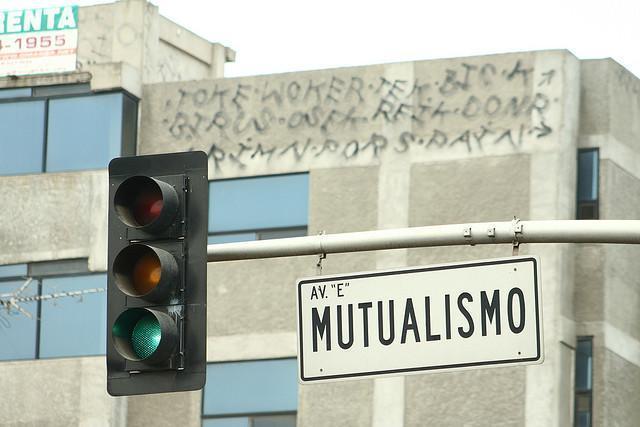How many orange cups are on the table?
Give a very brief answer. 0. 